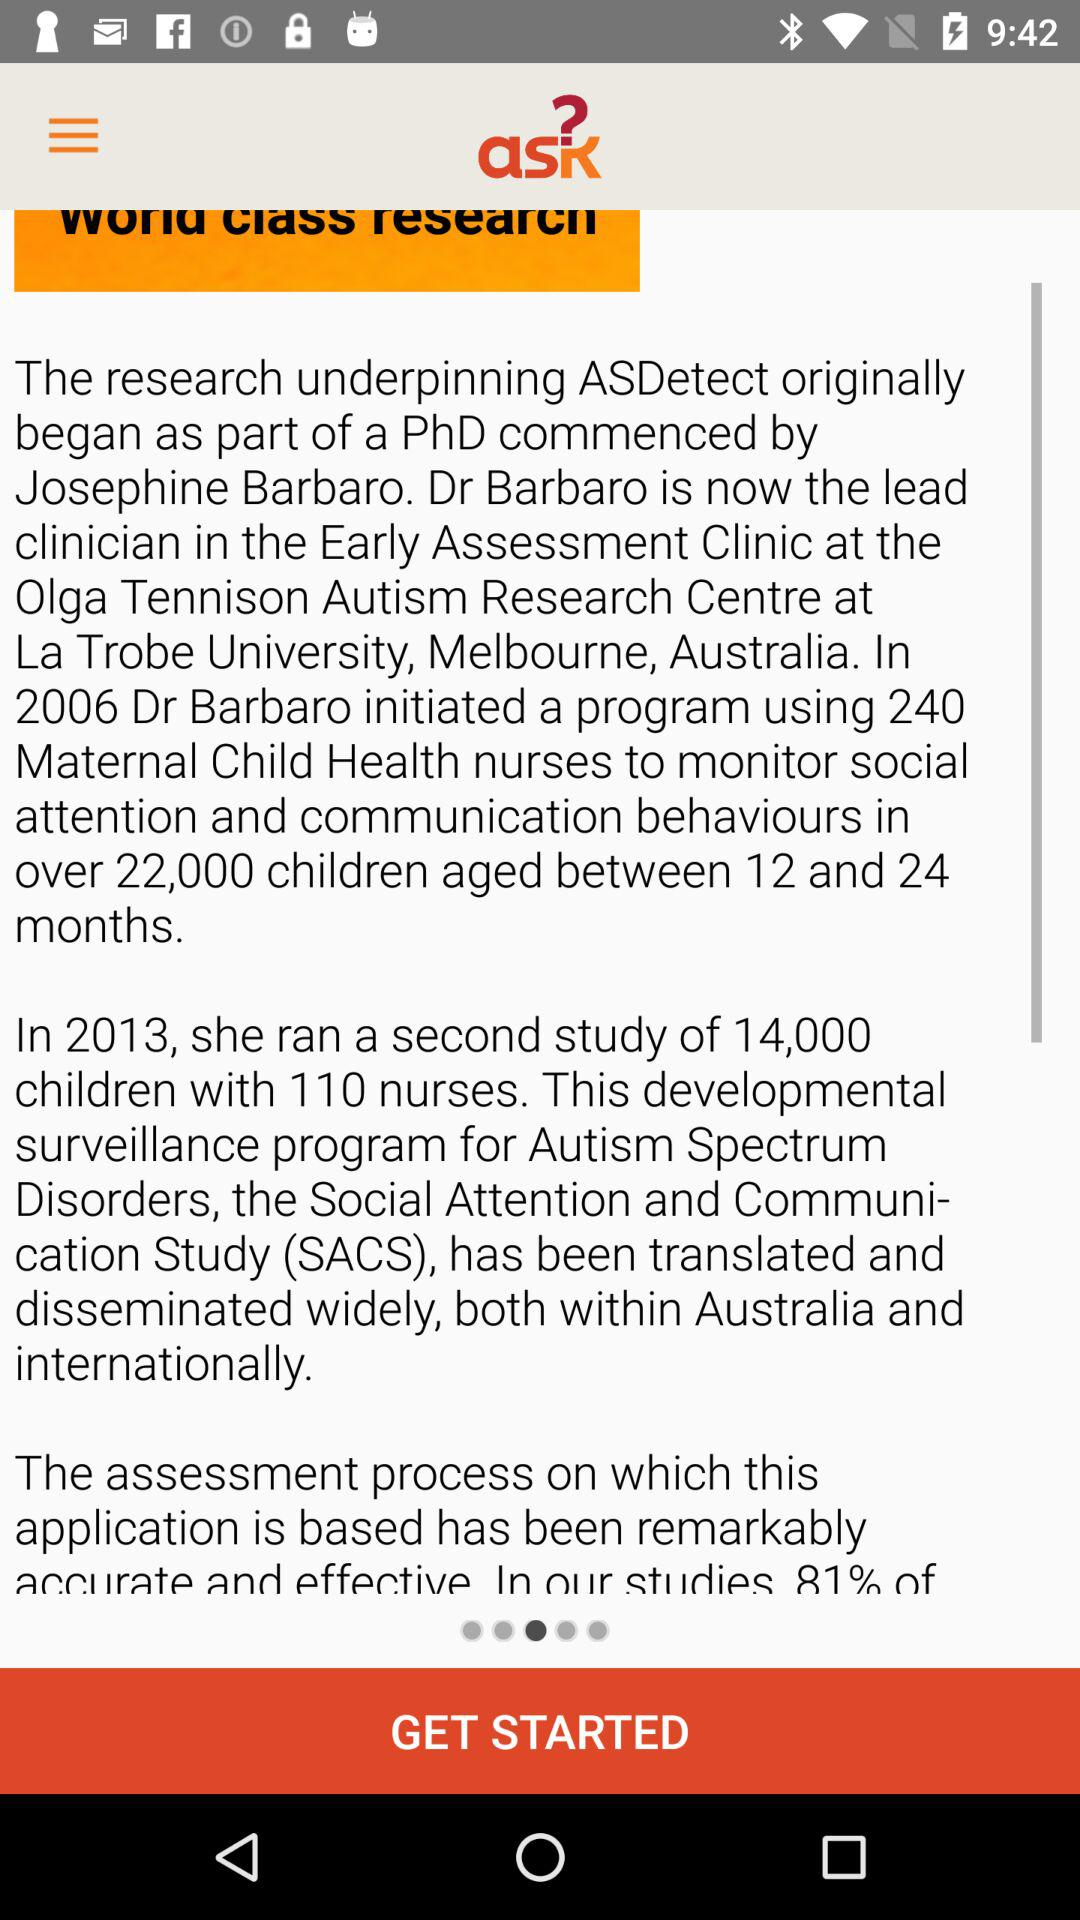How many years apart were the two studies conducted?
Answer the question using a single word or phrase. 7 